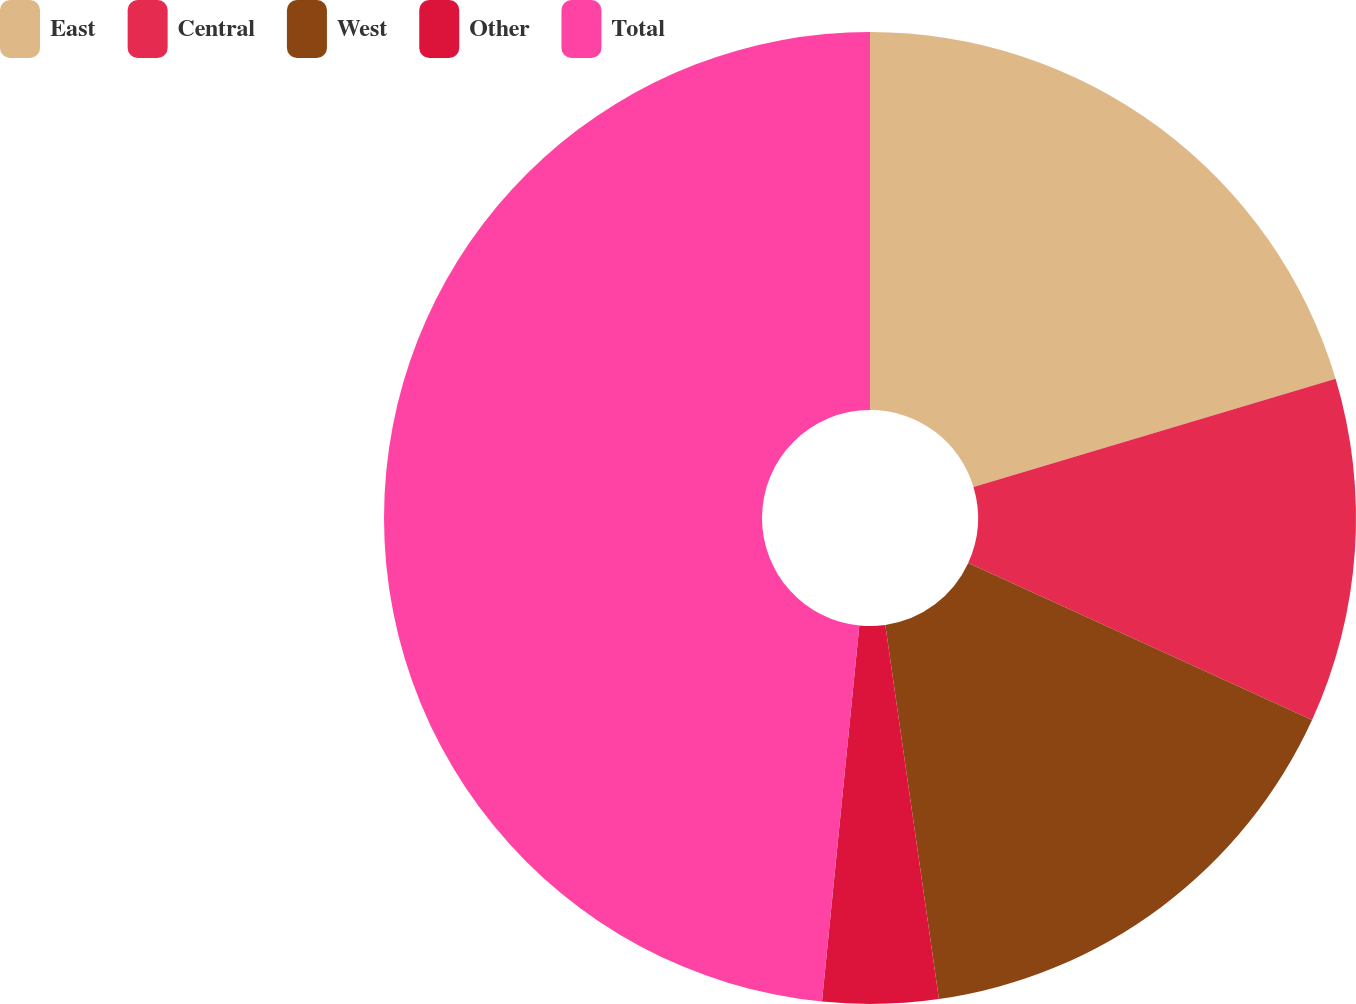Convert chart to OTSL. <chart><loc_0><loc_0><loc_500><loc_500><pie_chart><fcel>East<fcel>Central<fcel>West<fcel>Other<fcel>Total<nl><fcel>20.37%<fcel>11.45%<fcel>15.91%<fcel>3.84%<fcel>48.42%<nl></chart> 